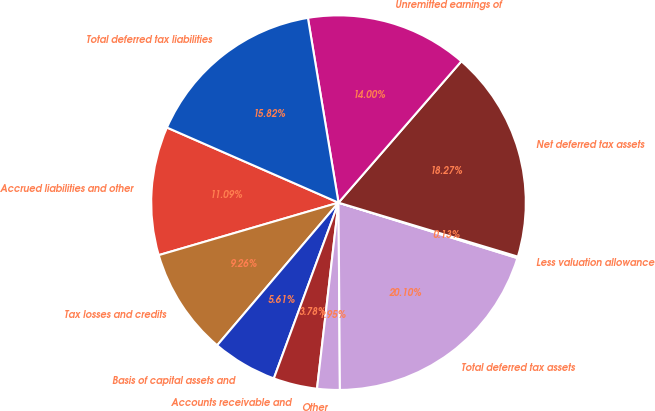Convert chart. <chart><loc_0><loc_0><loc_500><loc_500><pie_chart><fcel>Accrued liabilities and other<fcel>Tax losses and credits<fcel>Basis of capital assets and<fcel>Accounts receivable and<fcel>Other<fcel>Total deferred tax assets<fcel>Less valuation allowance<fcel>Net deferred tax assets<fcel>Unremitted earnings of<fcel>Total deferred tax liabilities<nl><fcel>11.09%<fcel>9.26%<fcel>5.61%<fcel>3.78%<fcel>1.95%<fcel>20.1%<fcel>0.13%<fcel>18.27%<fcel>14.0%<fcel>15.82%<nl></chart> 